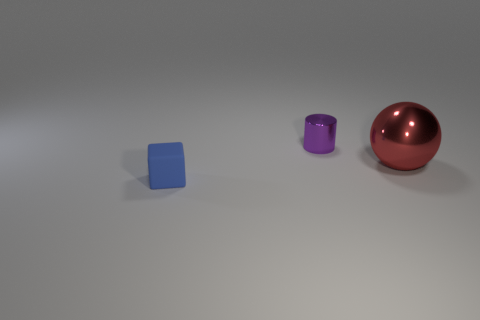Add 2 big red metal balls. How many objects exist? 5 Subtract all cylinders. How many objects are left? 2 Subtract all big shiny cubes. Subtract all small metallic cylinders. How many objects are left? 2 Add 3 purple objects. How many purple objects are left? 4 Add 3 large yellow rubber cylinders. How many large yellow rubber cylinders exist? 3 Subtract 1 purple cylinders. How many objects are left? 2 